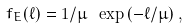Convert formula to latex. <formula><loc_0><loc_0><loc_500><loc_500>f _ { E } ( \ell ) = 1 / \mu \ \exp \left ( - { \ell } / { \mu } \right ) ,</formula> 